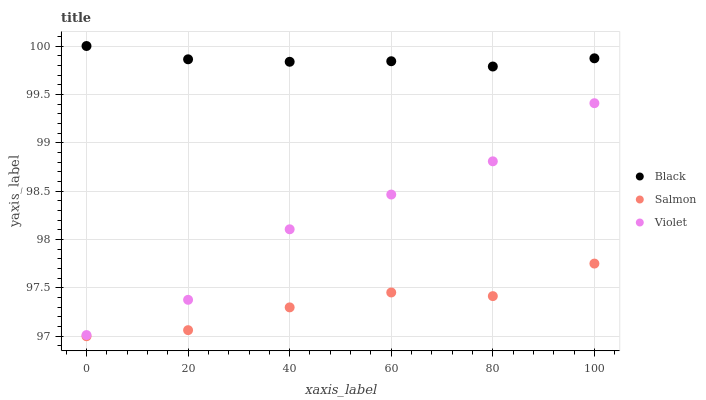Does Salmon have the minimum area under the curve?
Answer yes or no. Yes. Does Black have the maximum area under the curve?
Answer yes or no. Yes. Does Violet have the minimum area under the curve?
Answer yes or no. No. Does Violet have the maximum area under the curve?
Answer yes or no. No. Is Black the smoothest?
Answer yes or no. Yes. Is Violet the roughest?
Answer yes or no. Yes. Is Violet the smoothest?
Answer yes or no. No. Is Black the roughest?
Answer yes or no. No. Does Salmon have the lowest value?
Answer yes or no. Yes. Does Violet have the lowest value?
Answer yes or no. No. Does Black have the highest value?
Answer yes or no. Yes. Does Violet have the highest value?
Answer yes or no. No. Is Violet less than Black?
Answer yes or no. Yes. Is Black greater than Violet?
Answer yes or no. Yes. Does Violet intersect Black?
Answer yes or no. No. 